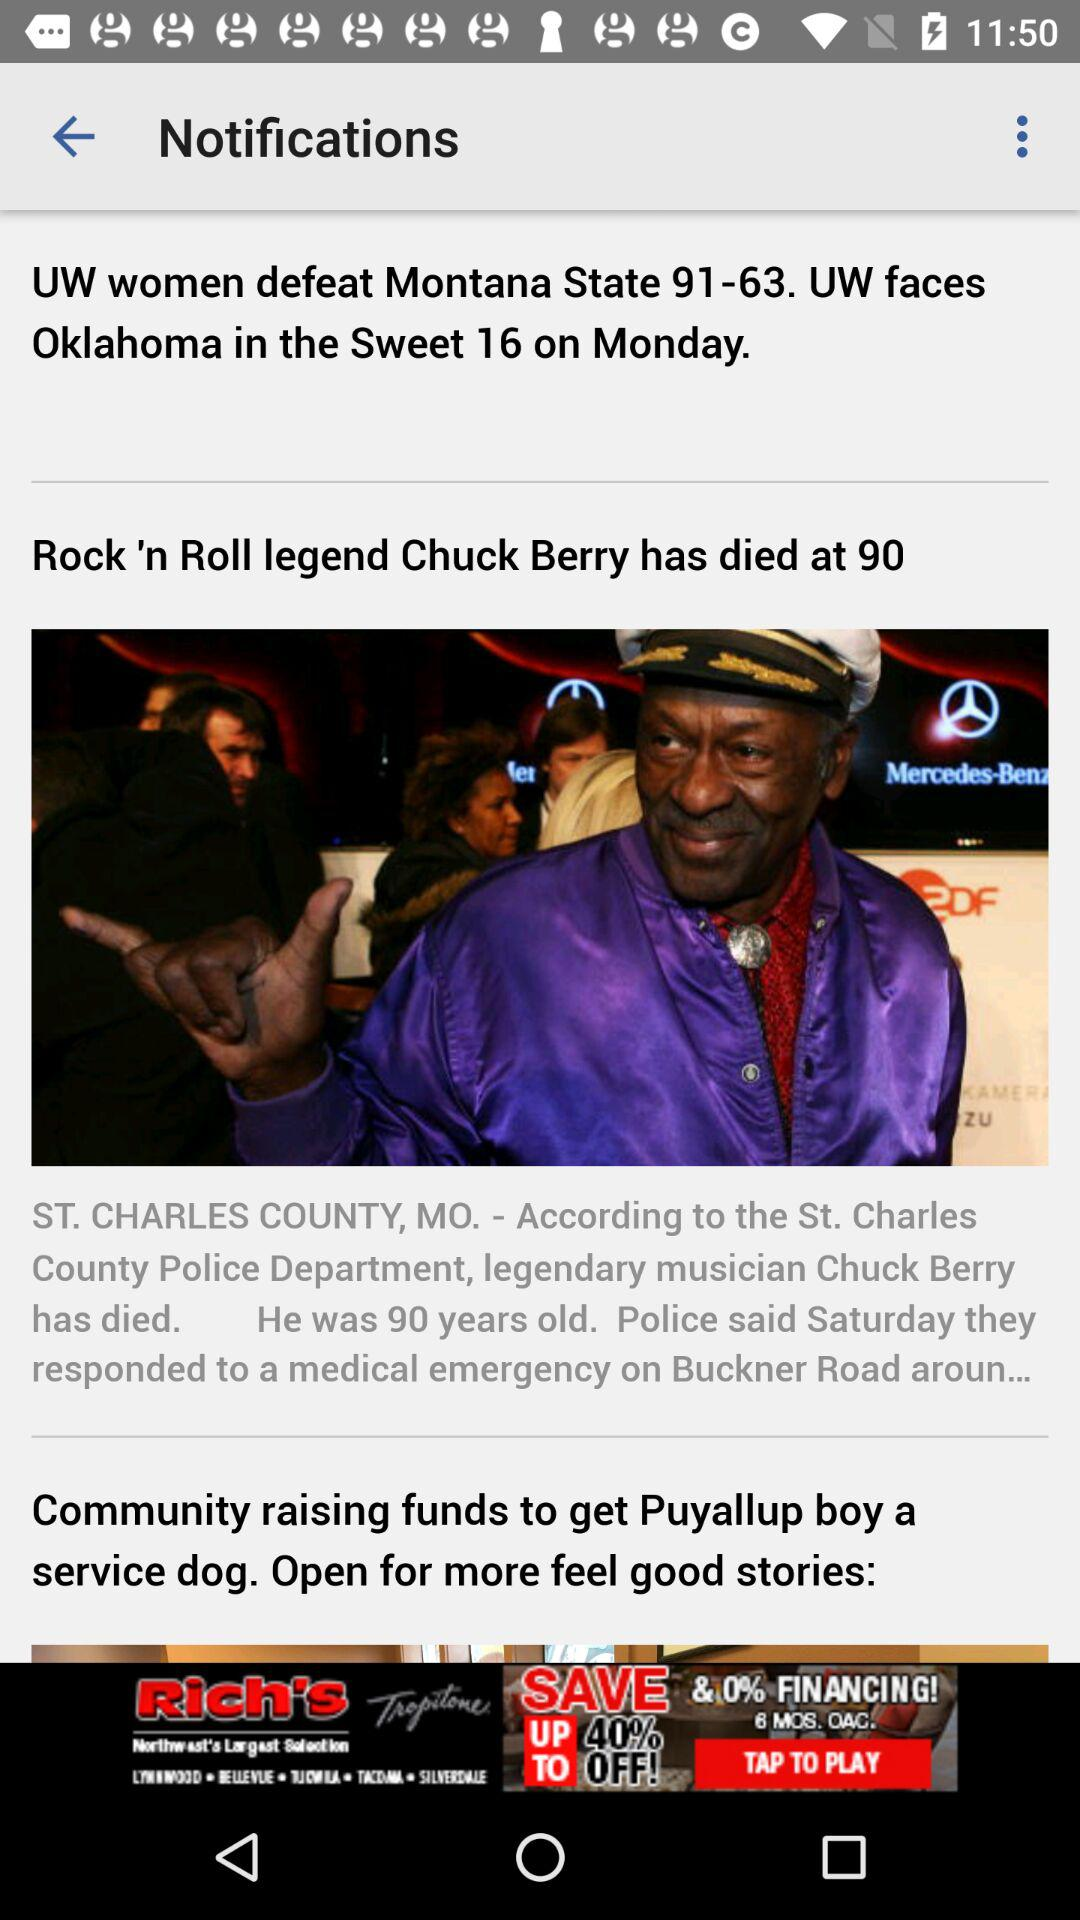At what age did Chuck Berry die? Chuck Berry died at the age of 90. 